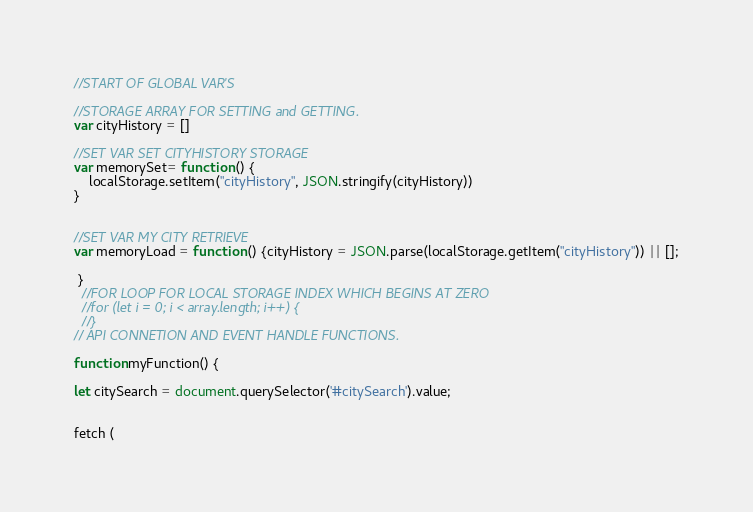<code> <loc_0><loc_0><loc_500><loc_500><_JavaScript_>
//START OF GLOBAL VAR'S

//STORAGE ARRAY FOR SETTING and GETTING. 
var cityHistory = []

//SET VAR SET CITYHISTORY STORAGE
var memorySet= function () {
    localStorage.setItem("cityHistory", JSON.stringify(cityHistory))
}


//SET VAR MY CITY RETRIEVE
var memoryLoad = function () {cityHistory = JSON.parse(localStorage.getItem("cityHistory")) || [];

 }
  //FOR LOOP FOR LOCAL STORAGE INDEX WHICH BEGINS AT ZERO
  //for (let i = 0; i < array.length; i++) {
  //}
// API CONNETION AND EVENT HANDLE FUNCTIONS.  

function myFunction() {

let citySearch = document.querySelector('#citySearch').value;


fetch (</code> 